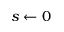<formula> <loc_0><loc_0><loc_500><loc_500>s \gets 0</formula> 